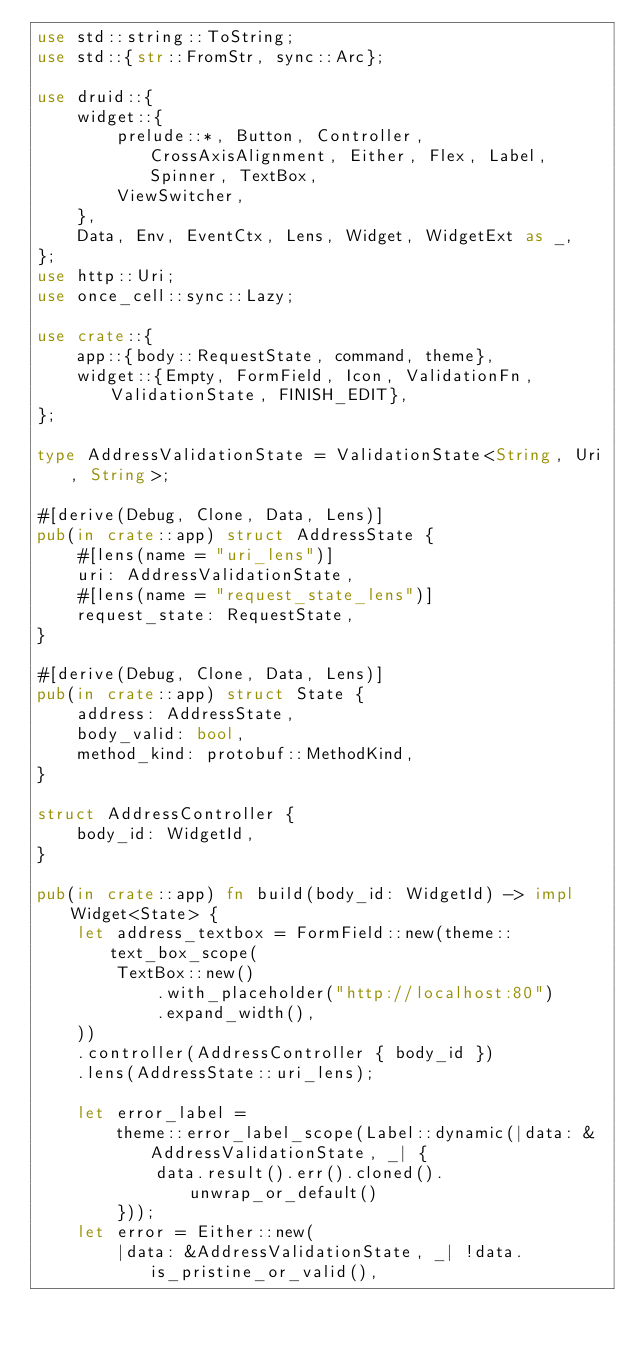<code> <loc_0><loc_0><loc_500><loc_500><_Rust_>use std::string::ToString;
use std::{str::FromStr, sync::Arc};

use druid::{
    widget::{
        prelude::*, Button, Controller, CrossAxisAlignment, Either, Flex, Label, Spinner, TextBox,
        ViewSwitcher,
    },
    Data, Env, EventCtx, Lens, Widget, WidgetExt as _,
};
use http::Uri;
use once_cell::sync::Lazy;

use crate::{
    app::{body::RequestState, command, theme},
    widget::{Empty, FormField, Icon, ValidationFn, ValidationState, FINISH_EDIT},
};

type AddressValidationState = ValidationState<String, Uri, String>;

#[derive(Debug, Clone, Data, Lens)]
pub(in crate::app) struct AddressState {
    #[lens(name = "uri_lens")]
    uri: AddressValidationState,
    #[lens(name = "request_state_lens")]
    request_state: RequestState,
}

#[derive(Debug, Clone, Data, Lens)]
pub(in crate::app) struct State {
    address: AddressState,
    body_valid: bool,
    method_kind: protobuf::MethodKind,
}

struct AddressController {
    body_id: WidgetId,
}

pub(in crate::app) fn build(body_id: WidgetId) -> impl Widget<State> {
    let address_textbox = FormField::new(theme::text_box_scope(
        TextBox::new()
            .with_placeholder("http://localhost:80")
            .expand_width(),
    ))
    .controller(AddressController { body_id })
    .lens(AddressState::uri_lens);

    let error_label =
        theme::error_label_scope(Label::dynamic(|data: &AddressValidationState, _| {
            data.result().err().cloned().unwrap_or_default()
        }));
    let error = Either::new(
        |data: &AddressValidationState, _| !data.is_pristine_or_valid(),</code> 